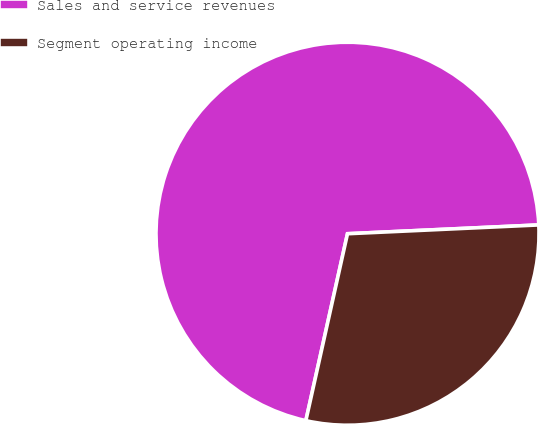Convert chart. <chart><loc_0><loc_0><loc_500><loc_500><pie_chart><fcel>Sales and service revenues<fcel>Segment operating income<nl><fcel>70.78%<fcel>29.22%<nl></chart> 